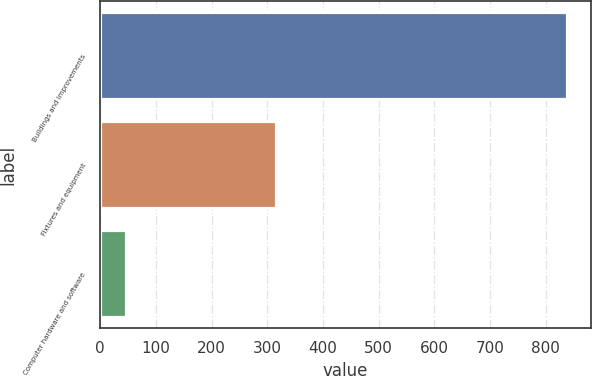Convert chart. <chart><loc_0><loc_0><loc_500><loc_500><bar_chart><fcel>Buildings and improvements<fcel>Fixtures and equipment<fcel>Computer hardware and software<nl><fcel>839<fcel>315<fcel>47<nl></chart> 